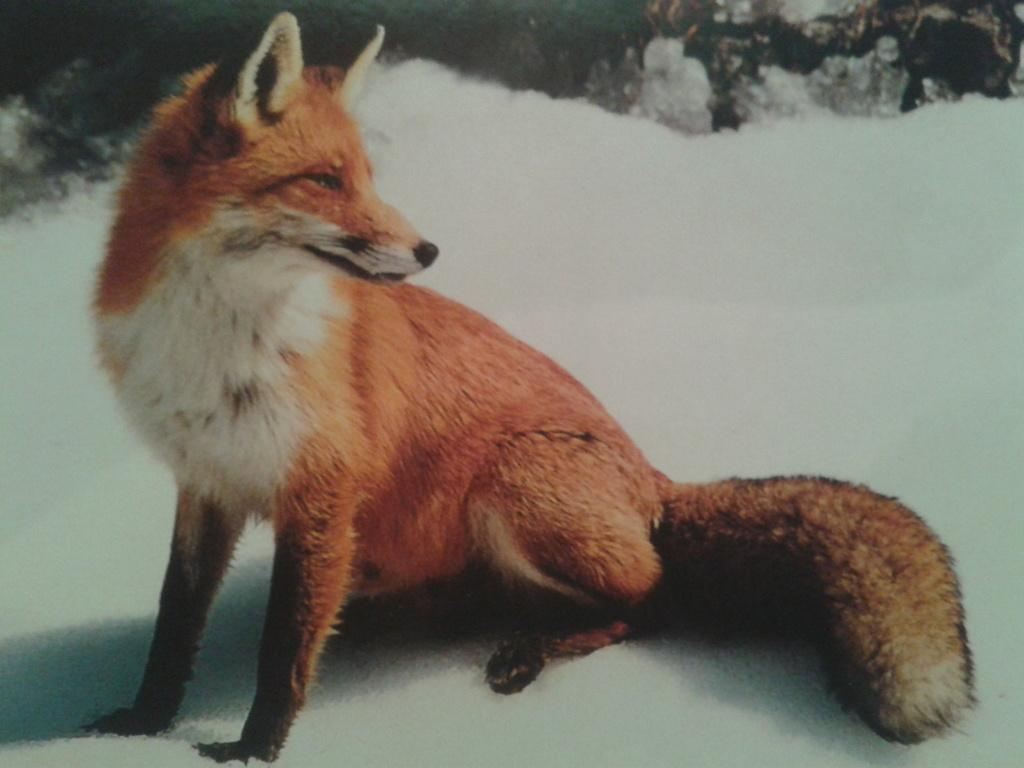What type of animal is in the image? The type of animal cannot be determined from the provided facts. What is the surface the animal is standing on? The animal is on snow. Can you describe the background of the image? The background of the image contains objects, but their specific nature cannot be determined from the provided facts. What type of wire is being used by the animal to build a nest in the image? There is no wire or nest visible in the image; the animal is simply standing on snow. 